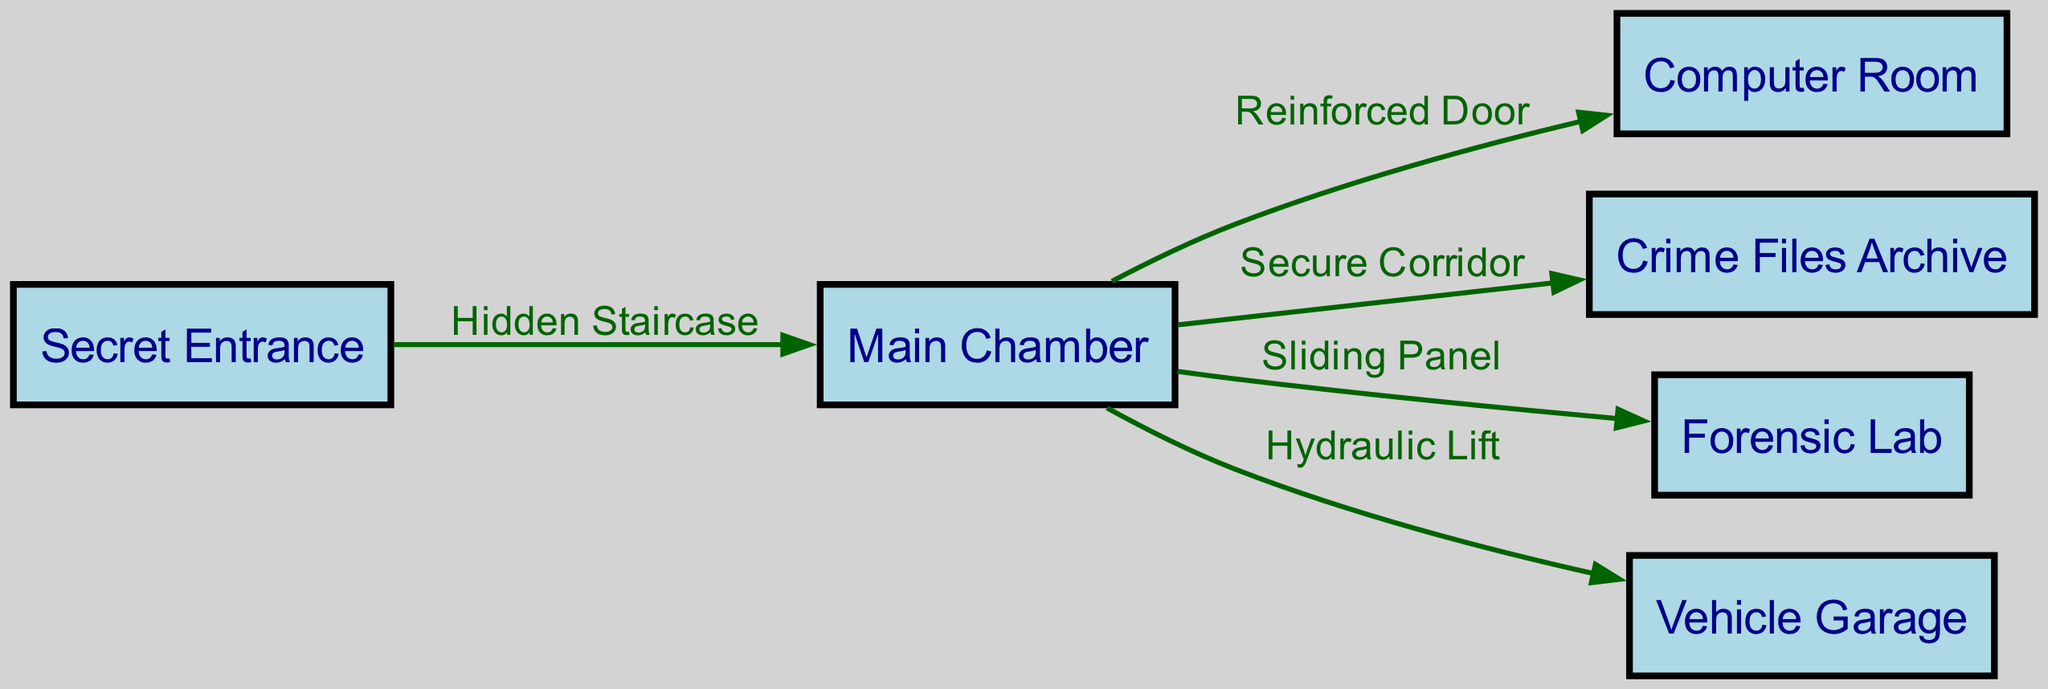What is the label of the node representing the access point to the crypt? The diagram lists a node labeled "Secret Entrance" which serves as the main access point to the crypt.
Answer: Secret Entrance How many nodes are present in the diagram? By counting the nodes listed in the provided data, there are six distinct nodes: Secret Entrance, Main Chamber, Computer Room, Crime Files Archive, Forensic Lab, and Vehicle Garage.
Answer: 6 What is the label of the edge connecting the Main Chamber to the Computer Room? The edge between the Main Chamber and the Computer Room is labeled "Reinforced Door," indicating the specific nature of the connection.
Answer: Reinforced Door What connects the Main Chamber and the Crime Files Archive? The connection from the Main Chamber to the Crime Files Archive is identified by a secure passage labeled "Secure Corridor."
Answer: Secure Corridor Which node can be accessed directly from the Main Chamber using a hydraulic mechanism? The diagram indicates that the node labeled "Vehicle Garage" is accessible directly from the Main Chamber through a "Hydraulic Lift."
Answer: Vehicle Garage How many edges are there in total in the diagram? The edges describe the connections between the nodes; there are five edges shown in the diagram that indicate pathways between the nodes.
Answer: 5 What kind of access connects the Secret Entrance to the Main Chamber? The connection from the Secret Entrance to the Main Chamber is represented by a "Hidden Staircase," implying a discreet entry method.
Answer: Hidden Staircase What is the label of the node representing the forensic analysis area? The node focused on forensic analysis is labeled "Forensic Lab" in the diagram.
Answer: Forensic Lab Which nodes are directly connected to the Main Chamber? The directly connected nodes to the Main Chamber are Computer Room, Crime Files Archive, Forensic Lab, and Vehicle Garage, showcasing multiple pathways from the central location.
Answer: 4 nodes 